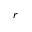Convert formula to latex. <formula><loc_0><loc_0><loc_500><loc_500>r</formula> 